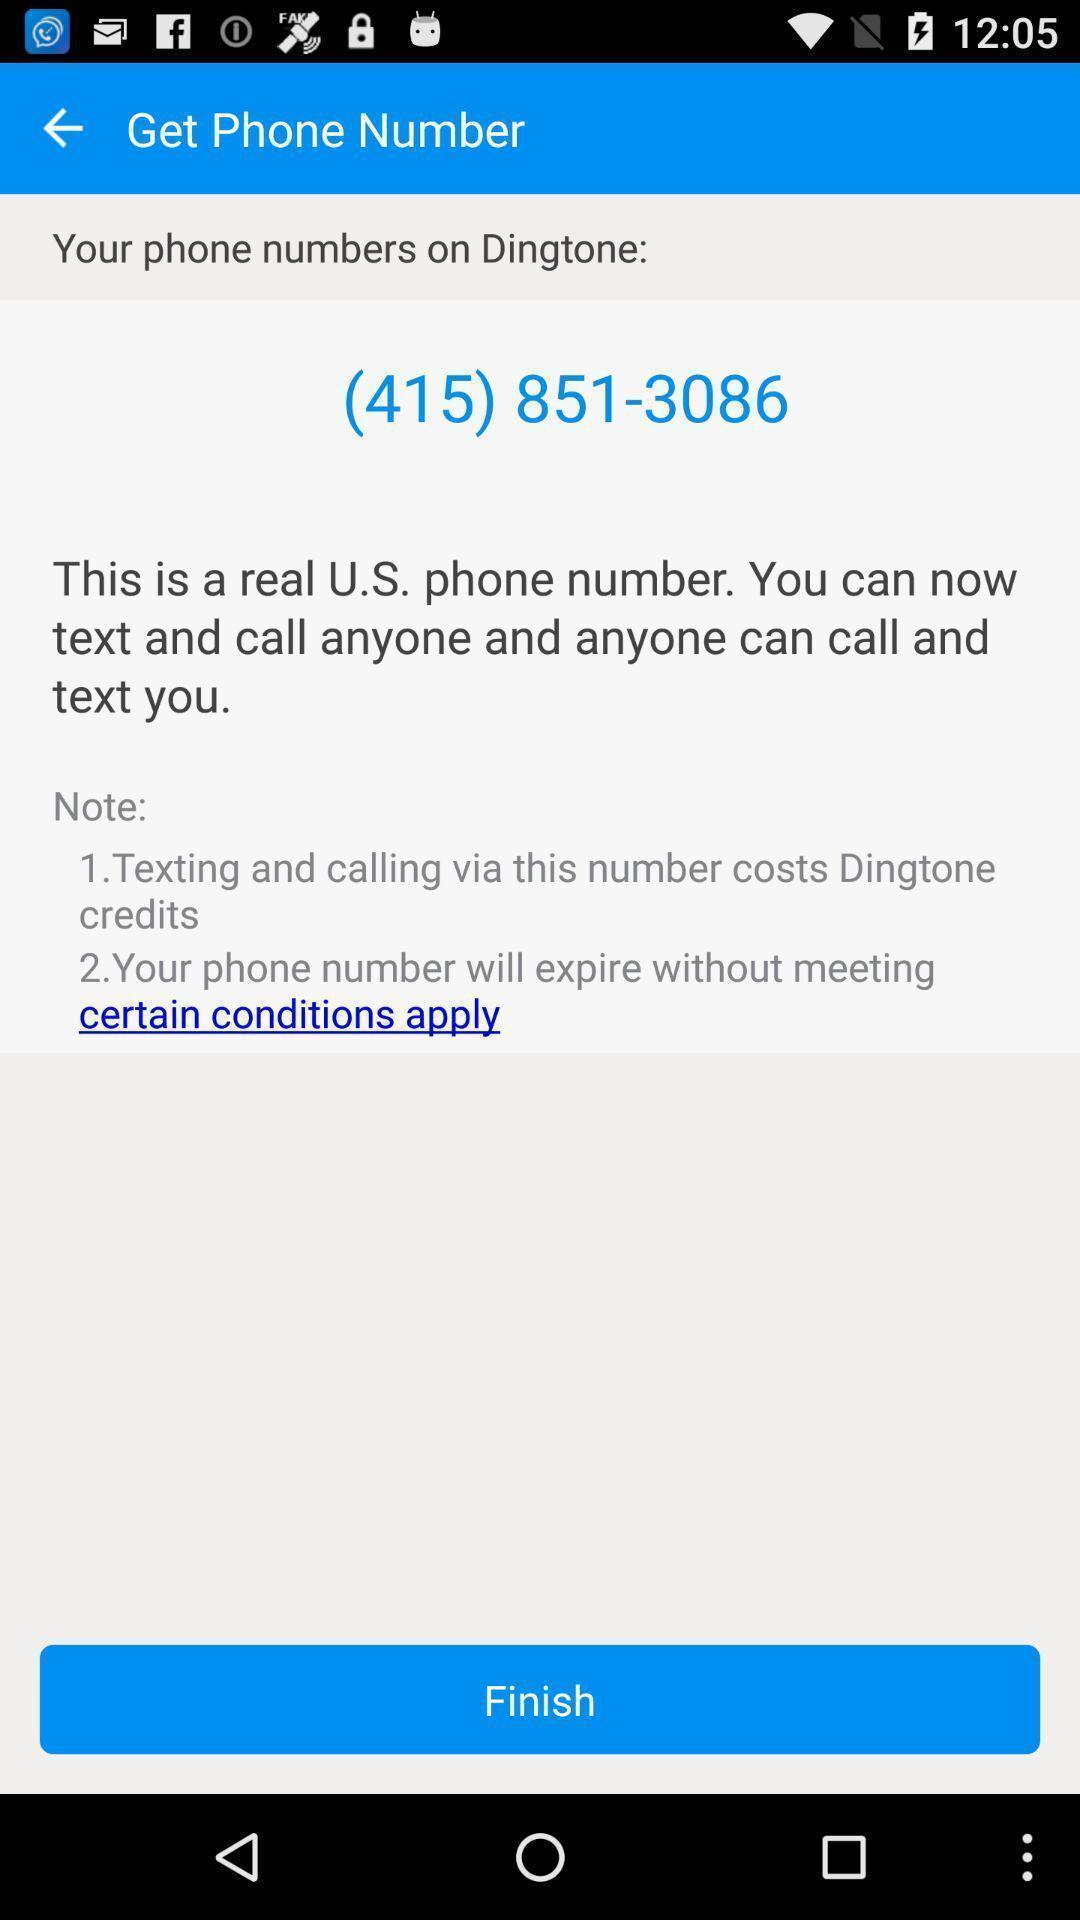Give me a summary of this screen capture. Screen displaying phone number. 